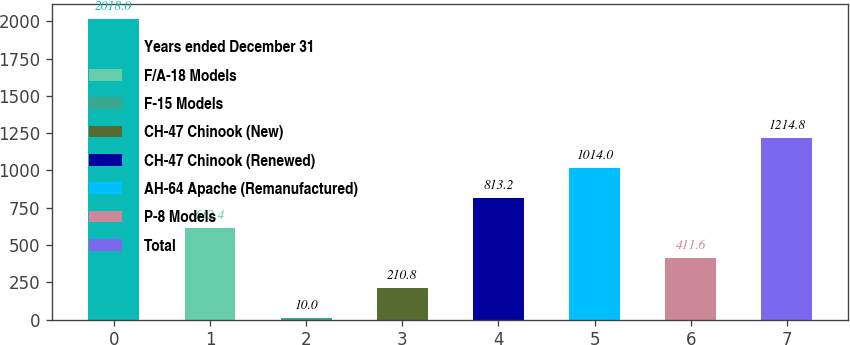Convert chart. <chart><loc_0><loc_0><loc_500><loc_500><bar_chart><fcel>Years ended December 31<fcel>F/A-18 Models<fcel>F-15 Models<fcel>CH-47 Chinook (New)<fcel>CH-47 Chinook (Renewed)<fcel>AH-64 Apache (Remanufactured)<fcel>P-8 Models<fcel>Total<nl><fcel>2018<fcel>612.4<fcel>10<fcel>210.8<fcel>813.2<fcel>1014<fcel>411.6<fcel>1214.8<nl></chart> 